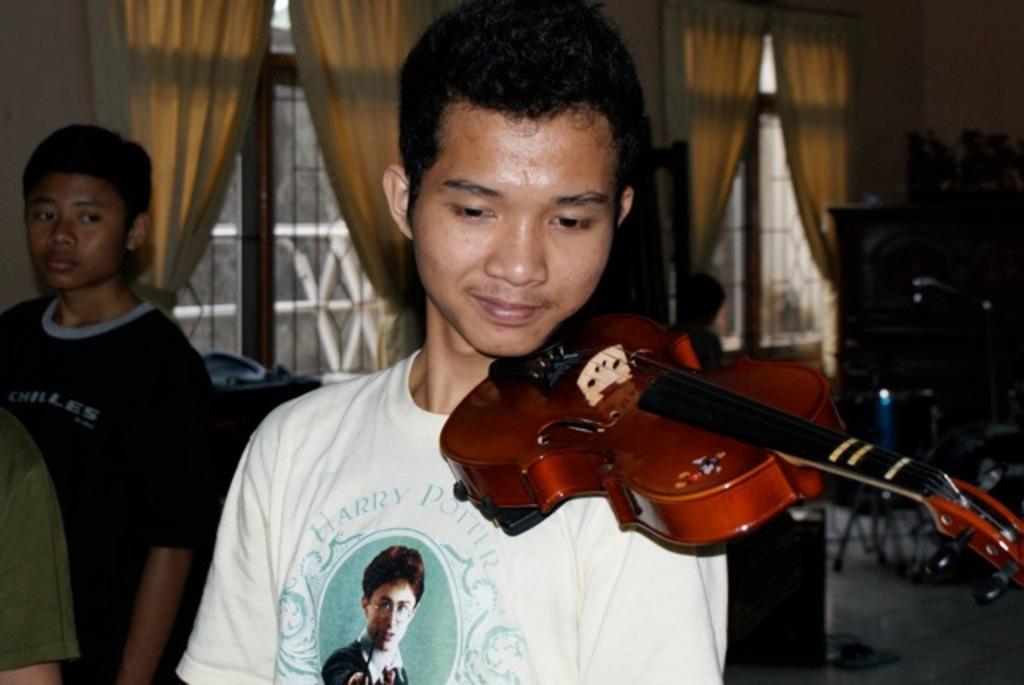Describe this image in one or two sentences. A boy is holding a violin. Behind him another boy is standing. In the background there are windows, curtains. 